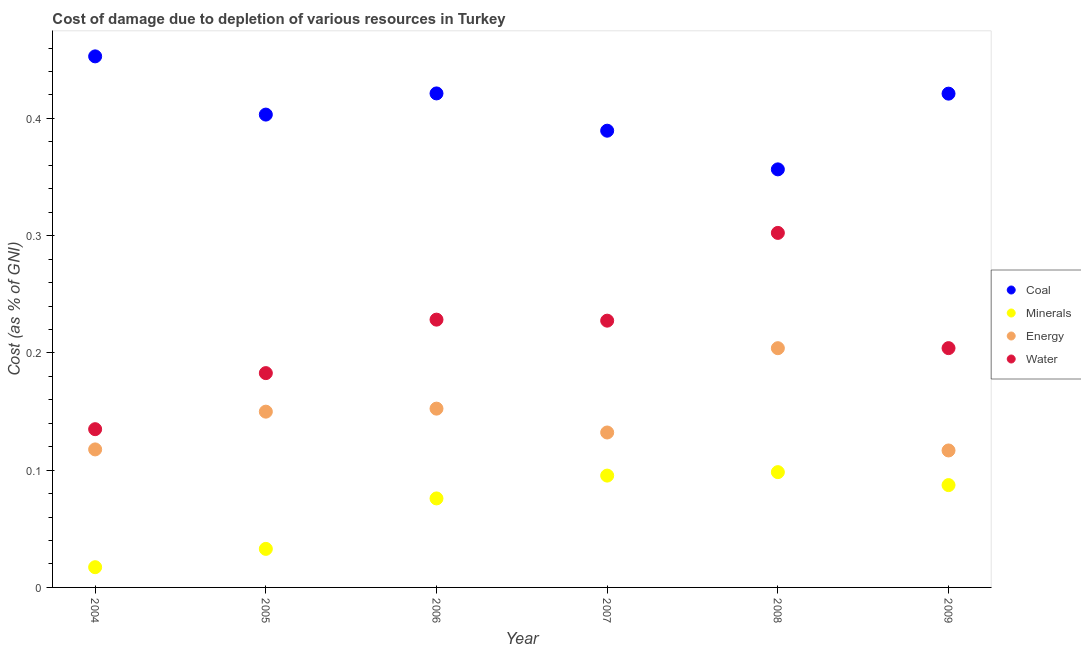What is the cost of damage due to depletion of minerals in 2004?
Ensure brevity in your answer.  0.02. Across all years, what is the maximum cost of damage due to depletion of energy?
Give a very brief answer. 0.2. Across all years, what is the minimum cost of damage due to depletion of coal?
Make the answer very short. 0.36. In which year was the cost of damage due to depletion of coal maximum?
Provide a succinct answer. 2004. In which year was the cost of damage due to depletion of minerals minimum?
Provide a short and direct response. 2004. What is the total cost of damage due to depletion of coal in the graph?
Ensure brevity in your answer.  2.44. What is the difference between the cost of damage due to depletion of water in 2005 and that in 2006?
Your response must be concise. -0.05. What is the difference between the cost of damage due to depletion of minerals in 2009 and the cost of damage due to depletion of energy in 2004?
Provide a succinct answer. -0.03. What is the average cost of damage due to depletion of minerals per year?
Give a very brief answer. 0.07. In the year 2004, what is the difference between the cost of damage due to depletion of energy and cost of damage due to depletion of coal?
Your response must be concise. -0.34. What is the ratio of the cost of damage due to depletion of coal in 2005 to that in 2008?
Provide a short and direct response. 1.13. Is the cost of damage due to depletion of coal in 2004 less than that in 2007?
Provide a succinct answer. No. What is the difference between the highest and the second highest cost of damage due to depletion of water?
Provide a succinct answer. 0.07. What is the difference between the highest and the lowest cost of damage due to depletion of coal?
Keep it short and to the point. 0.1. In how many years, is the cost of damage due to depletion of coal greater than the average cost of damage due to depletion of coal taken over all years?
Give a very brief answer. 3. Is the sum of the cost of damage due to depletion of coal in 2004 and 2005 greater than the maximum cost of damage due to depletion of minerals across all years?
Your response must be concise. Yes. Is it the case that in every year, the sum of the cost of damage due to depletion of minerals and cost of damage due to depletion of energy is greater than the sum of cost of damage due to depletion of water and cost of damage due to depletion of coal?
Offer a terse response. No. Does the cost of damage due to depletion of water monotonically increase over the years?
Ensure brevity in your answer.  No. Is the cost of damage due to depletion of energy strictly less than the cost of damage due to depletion of water over the years?
Offer a very short reply. Yes. What is the difference between two consecutive major ticks on the Y-axis?
Make the answer very short. 0.1. Does the graph contain any zero values?
Provide a short and direct response. No. Where does the legend appear in the graph?
Keep it short and to the point. Center right. How are the legend labels stacked?
Offer a terse response. Vertical. What is the title of the graph?
Keep it short and to the point. Cost of damage due to depletion of various resources in Turkey . What is the label or title of the Y-axis?
Your answer should be very brief. Cost (as % of GNI). What is the Cost (as % of GNI) of Coal in 2004?
Provide a succinct answer. 0.45. What is the Cost (as % of GNI) of Minerals in 2004?
Give a very brief answer. 0.02. What is the Cost (as % of GNI) of Energy in 2004?
Your answer should be very brief. 0.12. What is the Cost (as % of GNI) in Water in 2004?
Your answer should be very brief. 0.13. What is the Cost (as % of GNI) in Coal in 2005?
Ensure brevity in your answer.  0.4. What is the Cost (as % of GNI) in Minerals in 2005?
Provide a short and direct response. 0.03. What is the Cost (as % of GNI) in Energy in 2005?
Your response must be concise. 0.15. What is the Cost (as % of GNI) in Water in 2005?
Your answer should be compact. 0.18. What is the Cost (as % of GNI) in Coal in 2006?
Give a very brief answer. 0.42. What is the Cost (as % of GNI) of Minerals in 2006?
Keep it short and to the point. 0.08. What is the Cost (as % of GNI) of Energy in 2006?
Provide a succinct answer. 0.15. What is the Cost (as % of GNI) of Water in 2006?
Keep it short and to the point. 0.23. What is the Cost (as % of GNI) in Coal in 2007?
Your response must be concise. 0.39. What is the Cost (as % of GNI) in Minerals in 2007?
Give a very brief answer. 0.1. What is the Cost (as % of GNI) of Energy in 2007?
Your answer should be very brief. 0.13. What is the Cost (as % of GNI) of Water in 2007?
Your response must be concise. 0.23. What is the Cost (as % of GNI) in Coal in 2008?
Your response must be concise. 0.36. What is the Cost (as % of GNI) of Minerals in 2008?
Your answer should be very brief. 0.1. What is the Cost (as % of GNI) of Energy in 2008?
Provide a succinct answer. 0.2. What is the Cost (as % of GNI) in Water in 2008?
Offer a terse response. 0.3. What is the Cost (as % of GNI) in Coal in 2009?
Give a very brief answer. 0.42. What is the Cost (as % of GNI) in Minerals in 2009?
Offer a very short reply. 0.09. What is the Cost (as % of GNI) of Energy in 2009?
Your response must be concise. 0.12. What is the Cost (as % of GNI) of Water in 2009?
Your answer should be compact. 0.2. Across all years, what is the maximum Cost (as % of GNI) in Coal?
Offer a very short reply. 0.45. Across all years, what is the maximum Cost (as % of GNI) in Minerals?
Offer a terse response. 0.1. Across all years, what is the maximum Cost (as % of GNI) in Energy?
Keep it short and to the point. 0.2. Across all years, what is the maximum Cost (as % of GNI) of Water?
Provide a succinct answer. 0.3. Across all years, what is the minimum Cost (as % of GNI) of Coal?
Your response must be concise. 0.36. Across all years, what is the minimum Cost (as % of GNI) of Minerals?
Your answer should be compact. 0.02. Across all years, what is the minimum Cost (as % of GNI) in Energy?
Give a very brief answer. 0.12. Across all years, what is the minimum Cost (as % of GNI) in Water?
Offer a very short reply. 0.13. What is the total Cost (as % of GNI) of Coal in the graph?
Give a very brief answer. 2.44. What is the total Cost (as % of GNI) in Minerals in the graph?
Offer a very short reply. 0.41. What is the total Cost (as % of GNI) in Energy in the graph?
Offer a very short reply. 0.87. What is the total Cost (as % of GNI) of Water in the graph?
Keep it short and to the point. 1.28. What is the difference between the Cost (as % of GNI) in Coal in 2004 and that in 2005?
Offer a very short reply. 0.05. What is the difference between the Cost (as % of GNI) in Minerals in 2004 and that in 2005?
Offer a very short reply. -0.02. What is the difference between the Cost (as % of GNI) in Energy in 2004 and that in 2005?
Offer a terse response. -0.03. What is the difference between the Cost (as % of GNI) of Water in 2004 and that in 2005?
Your response must be concise. -0.05. What is the difference between the Cost (as % of GNI) of Coal in 2004 and that in 2006?
Make the answer very short. 0.03. What is the difference between the Cost (as % of GNI) in Minerals in 2004 and that in 2006?
Your answer should be compact. -0.06. What is the difference between the Cost (as % of GNI) of Energy in 2004 and that in 2006?
Your answer should be very brief. -0.03. What is the difference between the Cost (as % of GNI) of Water in 2004 and that in 2006?
Ensure brevity in your answer.  -0.09. What is the difference between the Cost (as % of GNI) in Coal in 2004 and that in 2007?
Offer a terse response. 0.06. What is the difference between the Cost (as % of GNI) in Minerals in 2004 and that in 2007?
Your response must be concise. -0.08. What is the difference between the Cost (as % of GNI) in Energy in 2004 and that in 2007?
Ensure brevity in your answer.  -0.01. What is the difference between the Cost (as % of GNI) of Water in 2004 and that in 2007?
Give a very brief answer. -0.09. What is the difference between the Cost (as % of GNI) in Coal in 2004 and that in 2008?
Ensure brevity in your answer.  0.1. What is the difference between the Cost (as % of GNI) in Minerals in 2004 and that in 2008?
Keep it short and to the point. -0.08. What is the difference between the Cost (as % of GNI) in Energy in 2004 and that in 2008?
Ensure brevity in your answer.  -0.09. What is the difference between the Cost (as % of GNI) of Water in 2004 and that in 2008?
Your response must be concise. -0.17. What is the difference between the Cost (as % of GNI) of Coal in 2004 and that in 2009?
Provide a succinct answer. 0.03. What is the difference between the Cost (as % of GNI) of Minerals in 2004 and that in 2009?
Your response must be concise. -0.07. What is the difference between the Cost (as % of GNI) of Energy in 2004 and that in 2009?
Your answer should be very brief. 0. What is the difference between the Cost (as % of GNI) in Water in 2004 and that in 2009?
Give a very brief answer. -0.07. What is the difference between the Cost (as % of GNI) of Coal in 2005 and that in 2006?
Make the answer very short. -0.02. What is the difference between the Cost (as % of GNI) in Minerals in 2005 and that in 2006?
Provide a succinct answer. -0.04. What is the difference between the Cost (as % of GNI) in Energy in 2005 and that in 2006?
Offer a terse response. -0. What is the difference between the Cost (as % of GNI) of Water in 2005 and that in 2006?
Keep it short and to the point. -0.05. What is the difference between the Cost (as % of GNI) in Coal in 2005 and that in 2007?
Your response must be concise. 0.01. What is the difference between the Cost (as % of GNI) in Minerals in 2005 and that in 2007?
Make the answer very short. -0.06. What is the difference between the Cost (as % of GNI) of Energy in 2005 and that in 2007?
Provide a short and direct response. 0.02. What is the difference between the Cost (as % of GNI) in Water in 2005 and that in 2007?
Your answer should be compact. -0.04. What is the difference between the Cost (as % of GNI) in Coal in 2005 and that in 2008?
Offer a very short reply. 0.05. What is the difference between the Cost (as % of GNI) of Minerals in 2005 and that in 2008?
Offer a very short reply. -0.07. What is the difference between the Cost (as % of GNI) in Energy in 2005 and that in 2008?
Provide a succinct answer. -0.05. What is the difference between the Cost (as % of GNI) of Water in 2005 and that in 2008?
Your answer should be very brief. -0.12. What is the difference between the Cost (as % of GNI) in Coal in 2005 and that in 2009?
Your response must be concise. -0.02. What is the difference between the Cost (as % of GNI) in Minerals in 2005 and that in 2009?
Provide a succinct answer. -0.05. What is the difference between the Cost (as % of GNI) of Energy in 2005 and that in 2009?
Ensure brevity in your answer.  0.03. What is the difference between the Cost (as % of GNI) of Water in 2005 and that in 2009?
Make the answer very short. -0.02. What is the difference between the Cost (as % of GNI) of Coal in 2006 and that in 2007?
Offer a terse response. 0.03. What is the difference between the Cost (as % of GNI) in Minerals in 2006 and that in 2007?
Provide a short and direct response. -0.02. What is the difference between the Cost (as % of GNI) in Energy in 2006 and that in 2007?
Make the answer very short. 0.02. What is the difference between the Cost (as % of GNI) in Water in 2006 and that in 2007?
Your answer should be compact. 0. What is the difference between the Cost (as % of GNI) in Coal in 2006 and that in 2008?
Your answer should be very brief. 0.06. What is the difference between the Cost (as % of GNI) of Minerals in 2006 and that in 2008?
Provide a succinct answer. -0.02. What is the difference between the Cost (as % of GNI) in Energy in 2006 and that in 2008?
Keep it short and to the point. -0.05. What is the difference between the Cost (as % of GNI) in Water in 2006 and that in 2008?
Your response must be concise. -0.07. What is the difference between the Cost (as % of GNI) of Coal in 2006 and that in 2009?
Your answer should be compact. 0. What is the difference between the Cost (as % of GNI) of Minerals in 2006 and that in 2009?
Offer a very short reply. -0.01. What is the difference between the Cost (as % of GNI) in Energy in 2006 and that in 2009?
Ensure brevity in your answer.  0.04. What is the difference between the Cost (as % of GNI) of Water in 2006 and that in 2009?
Your response must be concise. 0.02. What is the difference between the Cost (as % of GNI) of Coal in 2007 and that in 2008?
Your answer should be very brief. 0.03. What is the difference between the Cost (as % of GNI) of Minerals in 2007 and that in 2008?
Your answer should be compact. -0. What is the difference between the Cost (as % of GNI) in Energy in 2007 and that in 2008?
Make the answer very short. -0.07. What is the difference between the Cost (as % of GNI) of Water in 2007 and that in 2008?
Provide a short and direct response. -0.07. What is the difference between the Cost (as % of GNI) in Coal in 2007 and that in 2009?
Your answer should be very brief. -0.03. What is the difference between the Cost (as % of GNI) in Minerals in 2007 and that in 2009?
Offer a very short reply. 0.01. What is the difference between the Cost (as % of GNI) of Energy in 2007 and that in 2009?
Keep it short and to the point. 0.02. What is the difference between the Cost (as % of GNI) of Water in 2007 and that in 2009?
Offer a terse response. 0.02. What is the difference between the Cost (as % of GNI) in Coal in 2008 and that in 2009?
Make the answer very short. -0.06. What is the difference between the Cost (as % of GNI) of Minerals in 2008 and that in 2009?
Give a very brief answer. 0.01. What is the difference between the Cost (as % of GNI) in Energy in 2008 and that in 2009?
Your answer should be compact. 0.09. What is the difference between the Cost (as % of GNI) of Water in 2008 and that in 2009?
Offer a very short reply. 0.1. What is the difference between the Cost (as % of GNI) in Coal in 2004 and the Cost (as % of GNI) in Minerals in 2005?
Ensure brevity in your answer.  0.42. What is the difference between the Cost (as % of GNI) of Coal in 2004 and the Cost (as % of GNI) of Energy in 2005?
Your response must be concise. 0.3. What is the difference between the Cost (as % of GNI) of Coal in 2004 and the Cost (as % of GNI) of Water in 2005?
Your response must be concise. 0.27. What is the difference between the Cost (as % of GNI) of Minerals in 2004 and the Cost (as % of GNI) of Energy in 2005?
Your response must be concise. -0.13. What is the difference between the Cost (as % of GNI) in Minerals in 2004 and the Cost (as % of GNI) in Water in 2005?
Your answer should be very brief. -0.17. What is the difference between the Cost (as % of GNI) in Energy in 2004 and the Cost (as % of GNI) in Water in 2005?
Offer a very short reply. -0.07. What is the difference between the Cost (as % of GNI) of Coal in 2004 and the Cost (as % of GNI) of Minerals in 2006?
Provide a succinct answer. 0.38. What is the difference between the Cost (as % of GNI) of Coal in 2004 and the Cost (as % of GNI) of Energy in 2006?
Keep it short and to the point. 0.3. What is the difference between the Cost (as % of GNI) in Coal in 2004 and the Cost (as % of GNI) in Water in 2006?
Make the answer very short. 0.22. What is the difference between the Cost (as % of GNI) of Minerals in 2004 and the Cost (as % of GNI) of Energy in 2006?
Give a very brief answer. -0.14. What is the difference between the Cost (as % of GNI) in Minerals in 2004 and the Cost (as % of GNI) in Water in 2006?
Offer a very short reply. -0.21. What is the difference between the Cost (as % of GNI) in Energy in 2004 and the Cost (as % of GNI) in Water in 2006?
Make the answer very short. -0.11. What is the difference between the Cost (as % of GNI) in Coal in 2004 and the Cost (as % of GNI) in Minerals in 2007?
Your answer should be compact. 0.36. What is the difference between the Cost (as % of GNI) of Coal in 2004 and the Cost (as % of GNI) of Energy in 2007?
Keep it short and to the point. 0.32. What is the difference between the Cost (as % of GNI) in Coal in 2004 and the Cost (as % of GNI) in Water in 2007?
Your answer should be compact. 0.23. What is the difference between the Cost (as % of GNI) of Minerals in 2004 and the Cost (as % of GNI) of Energy in 2007?
Your answer should be compact. -0.11. What is the difference between the Cost (as % of GNI) of Minerals in 2004 and the Cost (as % of GNI) of Water in 2007?
Offer a terse response. -0.21. What is the difference between the Cost (as % of GNI) of Energy in 2004 and the Cost (as % of GNI) of Water in 2007?
Ensure brevity in your answer.  -0.11. What is the difference between the Cost (as % of GNI) of Coal in 2004 and the Cost (as % of GNI) of Minerals in 2008?
Provide a short and direct response. 0.35. What is the difference between the Cost (as % of GNI) in Coal in 2004 and the Cost (as % of GNI) in Energy in 2008?
Your response must be concise. 0.25. What is the difference between the Cost (as % of GNI) in Coal in 2004 and the Cost (as % of GNI) in Water in 2008?
Provide a succinct answer. 0.15. What is the difference between the Cost (as % of GNI) of Minerals in 2004 and the Cost (as % of GNI) of Energy in 2008?
Provide a short and direct response. -0.19. What is the difference between the Cost (as % of GNI) of Minerals in 2004 and the Cost (as % of GNI) of Water in 2008?
Provide a succinct answer. -0.29. What is the difference between the Cost (as % of GNI) of Energy in 2004 and the Cost (as % of GNI) of Water in 2008?
Your answer should be compact. -0.18. What is the difference between the Cost (as % of GNI) in Coal in 2004 and the Cost (as % of GNI) in Minerals in 2009?
Ensure brevity in your answer.  0.37. What is the difference between the Cost (as % of GNI) of Coal in 2004 and the Cost (as % of GNI) of Energy in 2009?
Your response must be concise. 0.34. What is the difference between the Cost (as % of GNI) of Coal in 2004 and the Cost (as % of GNI) of Water in 2009?
Ensure brevity in your answer.  0.25. What is the difference between the Cost (as % of GNI) in Minerals in 2004 and the Cost (as % of GNI) in Energy in 2009?
Your answer should be very brief. -0.1. What is the difference between the Cost (as % of GNI) of Minerals in 2004 and the Cost (as % of GNI) of Water in 2009?
Keep it short and to the point. -0.19. What is the difference between the Cost (as % of GNI) of Energy in 2004 and the Cost (as % of GNI) of Water in 2009?
Give a very brief answer. -0.09. What is the difference between the Cost (as % of GNI) in Coal in 2005 and the Cost (as % of GNI) in Minerals in 2006?
Keep it short and to the point. 0.33. What is the difference between the Cost (as % of GNI) of Coal in 2005 and the Cost (as % of GNI) of Energy in 2006?
Ensure brevity in your answer.  0.25. What is the difference between the Cost (as % of GNI) in Coal in 2005 and the Cost (as % of GNI) in Water in 2006?
Your answer should be very brief. 0.17. What is the difference between the Cost (as % of GNI) in Minerals in 2005 and the Cost (as % of GNI) in Energy in 2006?
Ensure brevity in your answer.  -0.12. What is the difference between the Cost (as % of GNI) in Minerals in 2005 and the Cost (as % of GNI) in Water in 2006?
Provide a succinct answer. -0.2. What is the difference between the Cost (as % of GNI) in Energy in 2005 and the Cost (as % of GNI) in Water in 2006?
Provide a succinct answer. -0.08. What is the difference between the Cost (as % of GNI) in Coal in 2005 and the Cost (as % of GNI) in Minerals in 2007?
Offer a terse response. 0.31. What is the difference between the Cost (as % of GNI) of Coal in 2005 and the Cost (as % of GNI) of Energy in 2007?
Your answer should be very brief. 0.27. What is the difference between the Cost (as % of GNI) of Coal in 2005 and the Cost (as % of GNI) of Water in 2007?
Your response must be concise. 0.18. What is the difference between the Cost (as % of GNI) of Minerals in 2005 and the Cost (as % of GNI) of Energy in 2007?
Your answer should be very brief. -0.1. What is the difference between the Cost (as % of GNI) in Minerals in 2005 and the Cost (as % of GNI) in Water in 2007?
Offer a terse response. -0.19. What is the difference between the Cost (as % of GNI) of Energy in 2005 and the Cost (as % of GNI) of Water in 2007?
Keep it short and to the point. -0.08. What is the difference between the Cost (as % of GNI) of Coal in 2005 and the Cost (as % of GNI) of Minerals in 2008?
Your answer should be compact. 0.3. What is the difference between the Cost (as % of GNI) of Coal in 2005 and the Cost (as % of GNI) of Energy in 2008?
Your response must be concise. 0.2. What is the difference between the Cost (as % of GNI) in Coal in 2005 and the Cost (as % of GNI) in Water in 2008?
Offer a terse response. 0.1. What is the difference between the Cost (as % of GNI) in Minerals in 2005 and the Cost (as % of GNI) in Energy in 2008?
Offer a very short reply. -0.17. What is the difference between the Cost (as % of GNI) of Minerals in 2005 and the Cost (as % of GNI) of Water in 2008?
Provide a succinct answer. -0.27. What is the difference between the Cost (as % of GNI) of Energy in 2005 and the Cost (as % of GNI) of Water in 2008?
Offer a very short reply. -0.15. What is the difference between the Cost (as % of GNI) of Coal in 2005 and the Cost (as % of GNI) of Minerals in 2009?
Your response must be concise. 0.32. What is the difference between the Cost (as % of GNI) of Coal in 2005 and the Cost (as % of GNI) of Energy in 2009?
Make the answer very short. 0.29. What is the difference between the Cost (as % of GNI) of Coal in 2005 and the Cost (as % of GNI) of Water in 2009?
Offer a very short reply. 0.2. What is the difference between the Cost (as % of GNI) in Minerals in 2005 and the Cost (as % of GNI) in Energy in 2009?
Provide a succinct answer. -0.08. What is the difference between the Cost (as % of GNI) of Minerals in 2005 and the Cost (as % of GNI) of Water in 2009?
Provide a short and direct response. -0.17. What is the difference between the Cost (as % of GNI) in Energy in 2005 and the Cost (as % of GNI) in Water in 2009?
Your answer should be very brief. -0.05. What is the difference between the Cost (as % of GNI) in Coal in 2006 and the Cost (as % of GNI) in Minerals in 2007?
Provide a short and direct response. 0.33. What is the difference between the Cost (as % of GNI) in Coal in 2006 and the Cost (as % of GNI) in Energy in 2007?
Ensure brevity in your answer.  0.29. What is the difference between the Cost (as % of GNI) in Coal in 2006 and the Cost (as % of GNI) in Water in 2007?
Keep it short and to the point. 0.19. What is the difference between the Cost (as % of GNI) in Minerals in 2006 and the Cost (as % of GNI) in Energy in 2007?
Your answer should be very brief. -0.06. What is the difference between the Cost (as % of GNI) in Minerals in 2006 and the Cost (as % of GNI) in Water in 2007?
Offer a terse response. -0.15. What is the difference between the Cost (as % of GNI) of Energy in 2006 and the Cost (as % of GNI) of Water in 2007?
Your answer should be compact. -0.07. What is the difference between the Cost (as % of GNI) in Coal in 2006 and the Cost (as % of GNI) in Minerals in 2008?
Give a very brief answer. 0.32. What is the difference between the Cost (as % of GNI) in Coal in 2006 and the Cost (as % of GNI) in Energy in 2008?
Provide a succinct answer. 0.22. What is the difference between the Cost (as % of GNI) in Coal in 2006 and the Cost (as % of GNI) in Water in 2008?
Offer a terse response. 0.12. What is the difference between the Cost (as % of GNI) of Minerals in 2006 and the Cost (as % of GNI) of Energy in 2008?
Your answer should be compact. -0.13. What is the difference between the Cost (as % of GNI) in Minerals in 2006 and the Cost (as % of GNI) in Water in 2008?
Provide a succinct answer. -0.23. What is the difference between the Cost (as % of GNI) in Energy in 2006 and the Cost (as % of GNI) in Water in 2008?
Give a very brief answer. -0.15. What is the difference between the Cost (as % of GNI) in Coal in 2006 and the Cost (as % of GNI) in Minerals in 2009?
Provide a short and direct response. 0.33. What is the difference between the Cost (as % of GNI) of Coal in 2006 and the Cost (as % of GNI) of Energy in 2009?
Provide a succinct answer. 0.3. What is the difference between the Cost (as % of GNI) in Coal in 2006 and the Cost (as % of GNI) in Water in 2009?
Make the answer very short. 0.22. What is the difference between the Cost (as % of GNI) of Minerals in 2006 and the Cost (as % of GNI) of Energy in 2009?
Give a very brief answer. -0.04. What is the difference between the Cost (as % of GNI) in Minerals in 2006 and the Cost (as % of GNI) in Water in 2009?
Your answer should be compact. -0.13. What is the difference between the Cost (as % of GNI) in Energy in 2006 and the Cost (as % of GNI) in Water in 2009?
Your response must be concise. -0.05. What is the difference between the Cost (as % of GNI) in Coal in 2007 and the Cost (as % of GNI) in Minerals in 2008?
Provide a short and direct response. 0.29. What is the difference between the Cost (as % of GNI) in Coal in 2007 and the Cost (as % of GNI) in Energy in 2008?
Provide a succinct answer. 0.19. What is the difference between the Cost (as % of GNI) in Coal in 2007 and the Cost (as % of GNI) in Water in 2008?
Provide a short and direct response. 0.09. What is the difference between the Cost (as % of GNI) in Minerals in 2007 and the Cost (as % of GNI) in Energy in 2008?
Offer a very short reply. -0.11. What is the difference between the Cost (as % of GNI) in Minerals in 2007 and the Cost (as % of GNI) in Water in 2008?
Provide a succinct answer. -0.21. What is the difference between the Cost (as % of GNI) of Energy in 2007 and the Cost (as % of GNI) of Water in 2008?
Offer a very short reply. -0.17. What is the difference between the Cost (as % of GNI) in Coal in 2007 and the Cost (as % of GNI) in Minerals in 2009?
Offer a terse response. 0.3. What is the difference between the Cost (as % of GNI) of Coal in 2007 and the Cost (as % of GNI) of Energy in 2009?
Make the answer very short. 0.27. What is the difference between the Cost (as % of GNI) of Coal in 2007 and the Cost (as % of GNI) of Water in 2009?
Make the answer very short. 0.19. What is the difference between the Cost (as % of GNI) of Minerals in 2007 and the Cost (as % of GNI) of Energy in 2009?
Offer a terse response. -0.02. What is the difference between the Cost (as % of GNI) of Minerals in 2007 and the Cost (as % of GNI) of Water in 2009?
Make the answer very short. -0.11. What is the difference between the Cost (as % of GNI) of Energy in 2007 and the Cost (as % of GNI) of Water in 2009?
Offer a very short reply. -0.07. What is the difference between the Cost (as % of GNI) in Coal in 2008 and the Cost (as % of GNI) in Minerals in 2009?
Your response must be concise. 0.27. What is the difference between the Cost (as % of GNI) in Coal in 2008 and the Cost (as % of GNI) in Energy in 2009?
Keep it short and to the point. 0.24. What is the difference between the Cost (as % of GNI) in Coal in 2008 and the Cost (as % of GNI) in Water in 2009?
Give a very brief answer. 0.15. What is the difference between the Cost (as % of GNI) in Minerals in 2008 and the Cost (as % of GNI) in Energy in 2009?
Offer a terse response. -0.02. What is the difference between the Cost (as % of GNI) of Minerals in 2008 and the Cost (as % of GNI) of Water in 2009?
Give a very brief answer. -0.11. What is the average Cost (as % of GNI) in Coal per year?
Give a very brief answer. 0.41. What is the average Cost (as % of GNI) in Minerals per year?
Make the answer very short. 0.07. What is the average Cost (as % of GNI) in Energy per year?
Your response must be concise. 0.15. What is the average Cost (as % of GNI) in Water per year?
Your answer should be very brief. 0.21. In the year 2004, what is the difference between the Cost (as % of GNI) in Coal and Cost (as % of GNI) in Minerals?
Offer a very short reply. 0.44. In the year 2004, what is the difference between the Cost (as % of GNI) of Coal and Cost (as % of GNI) of Energy?
Offer a very short reply. 0.34. In the year 2004, what is the difference between the Cost (as % of GNI) in Coal and Cost (as % of GNI) in Water?
Ensure brevity in your answer.  0.32. In the year 2004, what is the difference between the Cost (as % of GNI) of Minerals and Cost (as % of GNI) of Energy?
Provide a short and direct response. -0.1. In the year 2004, what is the difference between the Cost (as % of GNI) of Minerals and Cost (as % of GNI) of Water?
Keep it short and to the point. -0.12. In the year 2004, what is the difference between the Cost (as % of GNI) in Energy and Cost (as % of GNI) in Water?
Keep it short and to the point. -0.02. In the year 2005, what is the difference between the Cost (as % of GNI) in Coal and Cost (as % of GNI) in Minerals?
Provide a short and direct response. 0.37. In the year 2005, what is the difference between the Cost (as % of GNI) in Coal and Cost (as % of GNI) in Energy?
Keep it short and to the point. 0.25. In the year 2005, what is the difference between the Cost (as % of GNI) in Coal and Cost (as % of GNI) in Water?
Your response must be concise. 0.22. In the year 2005, what is the difference between the Cost (as % of GNI) of Minerals and Cost (as % of GNI) of Energy?
Offer a very short reply. -0.12. In the year 2005, what is the difference between the Cost (as % of GNI) in Minerals and Cost (as % of GNI) in Water?
Keep it short and to the point. -0.15. In the year 2005, what is the difference between the Cost (as % of GNI) of Energy and Cost (as % of GNI) of Water?
Your answer should be very brief. -0.03. In the year 2006, what is the difference between the Cost (as % of GNI) in Coal and Cost (as % of GNI) in Minerals?
Your answer should be very brief. 0.35. In the year 2006, what is the difference between the Cost (as % of GNI) of Coal and Cost (as % of GNI) of Energy?
Give a very brief answer. 0.27. In the year 2006, what is the difference between the Cost (as % of GNI) of Coal and Cost (as % of GNI) of Water?
Offer a very short reply. 0.19. In the year 2006, what is the difference between the Cost (as % of GNI) in Minerals and Cost (as % of GNI) in Energy?
Your answer should be compact. -0.08. In the year 2006, what is the difference between the Cost (as % of GNI) in Minerals and Cost (as % of GNI) in Water?
Offer a terse response. -0.15. In the year 2006, what is the difference between the Cost (as % of GNI) in Energy and Cost (as % of GNI) in Water?
Your response must be concise. -0.08. In the year 2007, what is the difference between the Cost (as % of GNI) of Coal and Cost (as % of GNI) of Minerals?
Offer a very short reply. 0.29. In the year 2007, what is the difference between the Cost (as % of GNI) in Coal and Cost (as % of GNI) in Energy?
Your response must be concise. 0.26. In the year 2007, what is the difference between the Cost (as % of GNI) of Coal and Cost (as % of GNI) of Water?
Offer a terse response. 0.16. In the year 2007, what is the difference between the Cost (as % of GNI) of Minerals and Cost (as % of GNI) of Energy?
Ensure brevity in your answer.  -0.04. In the year 2007, what is the difference between the Cost (as % of GNI) in Minerals and Cost (as % of GNI) in Water?
Provide a succinct answer. -0.13. In the year 2007, what is the difference between the Cost (as % of GNI) in Energy and Cost (as % of GNI) in Water?
Give a very brief answer. -0.1. In the year 2008, what is the difference between the Cost (as % of GNI) in Coal and Cost (as % of GNI) in Minerals?
Make the answer very short. 0.26. In the year 2008, what is the difference between the Cost (as % of GNI) in Coal and Cost (as % of GNI) in Energy?
Offer a terse response. 0.15. In the year 2008, what is the difference between the Cost (as % of GNI) of Coal and Cost (as % of GNI) of Water?
Your answer should be compact. 0.05. In the year 2008, what is the difference between the Cost (as % of GNI) of Minerals and Cost (as % of GNI) of Energy?
Keep it short and to the point. -0.11. In the year 2008, what is the difference between the Cost (as % of GNI) in Minerals and Cost (as % of GNI) in Water?
Your answer should be very brief. -0.2. In the year 2008, what is the difference between the Cost (as % of GNI) in Energy and Cost (as % of GNI) in Water?
Provide a succinct answer. -0.1. In the year 2009, what is the difference between the Cost (as % of GNI) in Coal and Cost (as % of GNI) in Minerals?
Keep it short and to the point. 0.33. In the year 2009, what is the difference between the Cost (as % of GNI) of Coal and Cost (as % of GNI) of Energy?
Provide a short and direct response. 0.3. In the year 2009, what is the difference between the Cost (as % of GNI) in Coal and Cost (as % of GNI) in Water?
Your answer should be compact. 0.22. In the year 2009, what is the difference between the Cost (as % of GNI) of Minerals and Cost (as % of GNI) of Energy?
Keep it short and to the point. -0.03. In the year 2009, what is the difference between the Cost (as % of GNI) in Minerals and Cost (as % of GNI) in Water?
Your response must be concise. -0.12. In the year 2009, what is the difference between the Cost (as % of GNI) in Energy and Cost (as % of GNI) in Water?
Give a very brief answer. -0.09. What is the ratio of the Cost (as % of GNI) in Coal in 2004 to that in 2005?
Your answer should be compact. 1.12. What is the ratio of the Cost (as % of GNI) in Minerals in 2004 to that in 2005?
Offer a terse response. 0.52. What is the ratio of the Cost (as % of GNI) in Energy in 2004 to that in 2005?
Your response must be concise. 0.79. What is the ratio of the Cost (as % of GNI) of Water in 2004 to that in 2005?
Give a very brief answer. 0.74. What is the ratio of the Cost (as % of GNI) of Coal in 2004 to that in 2006?
Make the answer very short. 1.07. What is the ratio of the Cost (as % of GNI) in Minerals in 2004 to that in 2006?
Offer a terse response. 0.23. What is the ratio of the Cost (as % of GNI) in Energy in 2004 to that in 2006?
Provide a succinct answer. 0.77. What is the ratio of the Cost (as % of GNI) in Water in 2004 to that in 2006?
Your answer should be very brief. 0.59. What is the ratio of the Cost (as % of GNI) in Coal in 2004 to that in 2007?
Ensure brevity in your answer.  1.16. What is the ratio of the Cost (as % of GNI) in Minerals in 2004 to that in 2007?
Ensure brevity in your answer.  0.18. What is the ratio of the Cost (as % of GNI) in Energy in 2004 to that in 2007?
Provide a succinct answer. 0.89. What is the ratio of the Cost (as % of GNI) in Water in 2004 to that in 2007?
Provide a short and direct response. 0.59. What is the ratio of the Cost (as % of GNI) in Coal in 2004 to that in 2008?
Provide a succinct answer. 1.27. What is the ratio of the Cost (as % of GNI) in Minerals in 2004 to that in 2008?
Your answer should be compact. 0.18. What is the ratio of the Cost (as % of GNI) in Energy in 2004 to that in 2008?
Provide a short and direct response. 0.58. What is the ratio of the Cost (as % of GNI) in Water in 2004 to that in 2008?
Your answer should be very brief. 0.45. What is the ratio of the Cost (as % of GNI) of Coal in 2004 to that in 2009?
Make the answer very short. 1.08. What is the ratio of the Cost (as % of GNI) in Minerals in 2004 to that in 2009?
Make the answer very short. 0.2. What is the ratio of the Cost (as % of GNI) in Energy in 2004 to that in 2009?
Make the answer very short. 1.01. What is the ratio of the Cost (as % of GNI) in Water in 2004 to that in 2009?
Make the answer very short. 0.66. What is the ratio of the Cost (as % of GNI) in Coal in 2005 to that in 2006?
Keep it short and to the point. 0.96. What is the ratio of the Cost (as % of GNI) of Minerals in 2005 to that in 2006?
Provide a succinct answer. 0.43. What is the ratio of the Cost (as % of GNI) in Energy in 2005 to that in 2006?
Give a very brief answer. 0.98. What is the ratio of the Cost (as % of GNI) of Water in 2005 to that in 2006?
Provide a short and direct response. 0.8. What is the ratio of the Cost (as % of GNI) of Coal in 2005 to that in 2007?
Ensure brevity in your answer.  1.04. What is the ratio of the Cost (as % of GNI) in Minerals in 2005 to that in 2007?
Offer a very short reply. 0.34. What is the ratio of the Cost (as % of GNI) of Energy in 2005 to that in 2007?
Keep it short and to the point. 1.13. What is the ratio of the Cost (as % of GNI) of Water in 2005 to that in 2007?
Provide a succinct answer. 0.8. What is the ratio of the Cost (as % of GNI) of Coal in 2005 to that in 2008?
Ensure brevity in your answer.  1.13. What is the ratio of the Cost (as % of GNI) of Minerals in 2005 to that in 2008?
Offer a very short reply. 0.33. What is the ratio of the Cost (as % of GNI) in Energy in 2005 to that in 2008?
Offer a terse response. 0.73. What is the ratio of the Cost (as % of GNI) in Water in 2005 to that in 2008?
Give a very brief answer. 0.6. What is the ratio of the Cost (as % of GNI) in Coal in 2005 to that in 2009?
Offer a terse response. 0.96. What is the ratio of the Cost (as % of GNI) in Minerals in 2005 to that in 2009?
Ensure brevity in your answer.  0.38. What is the ratio of the Cost (as % of GNI) of Energy in 2005 to that in 2009?
Ensure brevity in your answer.  1.28. What is the ratio of the Cost (as % of GNI) of Water in 2005 to that in 2009?
Your answer should be very brief. 0.9. What is the ratio of the Cost (as % of GNI) of Coal in 2006 to that in 2007?
Offer a terse response. 1.08. What is the ratio of the Cost (as % of GNI) in Minerals in 2006 to that in 2007?
Keep it short and to the point. 0.8. What is the ratio of the Cost (as % of GNI) in Energy in 2006 to that in 2007?
Provide a short and direct response. 1.15. What is the ratio of the Cost (as % of GNI) of Coal in 2006 to that in 2008?
Give a very brief answer. 1.18. What is the ratio of the Cost (as % of GNI) of Minerals in 2006 to that in 2008?
Provide a succinct answer. 0.77. What is the ratio of the Cost (as % of GNI) in Energy in 2006 to that in 2008?
Make the answer very short. 0.75. What is the ratio of the Cost (as % of GNI) in Water in 2006 to that in 2008?
Provide a short and direct response. 0.76. What is the ratio of the Cost (as % of GNI) in Minerals in 2006 to that in 2009?
Your answer should be compact. 0.87. What is the ratio of the Cost (as % of GNI) of Energy in 2006 to that in 2009?
Your answer should be very brief. 1.31. What is the ratio of the Cost (as % of GNI) in Water in 2006 to that in 2009?
Offer a terse response. 1.12. What is the ratio of the Cost (as % of GNI) in Coal in 2007 to that in 2008?
Make the answer very short. 1.09. What is the ratio of the Cost (as % of GNI) in Minerals in 2007 to that in 2008?
Offer a terse response. 0.97. What is the ratio of the Cost (as % of GNI) in Energy in 2007 to that in 2008?
Provide a succinct answer. 0.65. What is the ratio of the Cost (as % of GNI) in Water in 2007 to that in 2008?
Your answer should be very brief. 0.75. What is the ratio of the Cost (as % of GNI) of Coal in 2007 to that in 2009?
Your response must be concise. 0.93. What is the ratio of the Cost (as % of GNI) in Minerals in 2007 to that in 2009?
Keep it short and to the point. 1.09. What is the ratio of the Cost (as % of GNI) of Energy in 2007 to that in 2009?
Provide a short and direct response. 1.13. What is the ratio of the Cost (as % of GNI) of Water in 2007 to that in 2009?
Your response must be concise. 1.11. What is the ratio of the Cost (as % of GNI) of Coal in 2008 to that in 2009?
Make the answer very short. 0.85. What is the ratio of the Cost (as % of GNI) of Minerals in 2008 to that in 2009?
Provide a succinct answer. 1.13. What is the ratio of the Cost (as % of GNI) of Energy in 2008 to that in 2009?
Offer a terse response. 1.75. What is the ratio of the Cost (as % of GNI) of Water in 2008 to that in 2009?
Provide a succinct answer. 1.48. What is the difference between the highest and the second highest Cost (as % of GNI) in Coal?
Keep it short and to the point. 0.03. What is the difference between the highest and the second highest Cost (as % of GNI) of Minerals?
Your response must be concise. 0. What is the difference between the highest and the second highest Cost (as % of GNI) in Energy?
Your response must be concise. 0.05. What is the difference between the highest and the second highest Cost (as % of GNI) in Water?
Ensure brevity in your answer.  0.07. What is the difference between the highest and the lowest Cost (as % of GNI) of Coal?
Offer a very short reply. 0.1. What is the difference between the highest and the lowest Cost (as % of GNI) in Minerals?
Give a very brief answer. 0.08. What is the difference between the highest and the lowest Cost (as % of GNI) in Energy?
Offer a very short reply. 0.09. What is the difference between the highest and the lowest Cost (as % of GNI) of Water?
Provide a short and direct response. 0.17. 